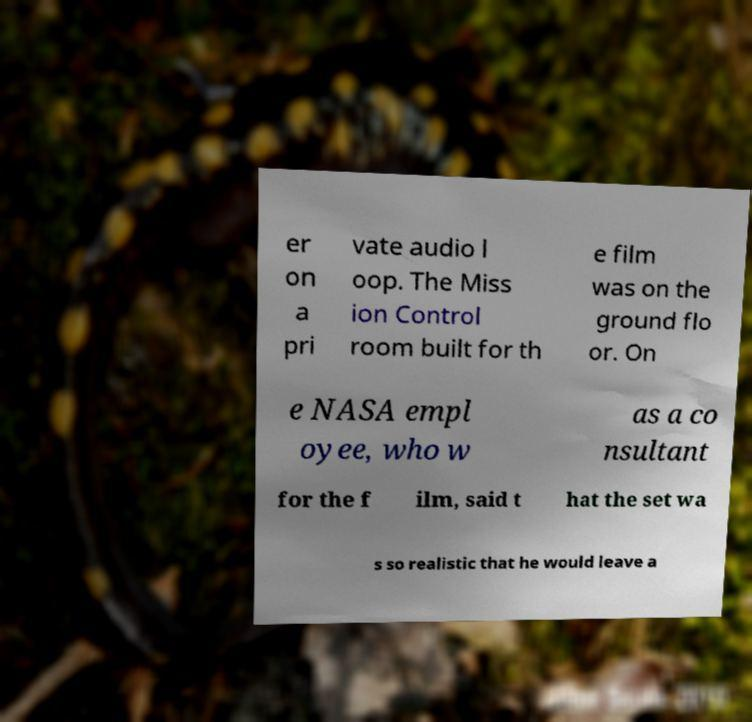What messages or text are displayed in this image? I need them in a readable, typed format. er on a pri vate audio l oop. The Miss ion Control room built for th e film was on the ground flo or. On e NASA empl oyee, who w as a co nsultant for the f ilm, said t hat the set wa s so realistic that he would leave a 